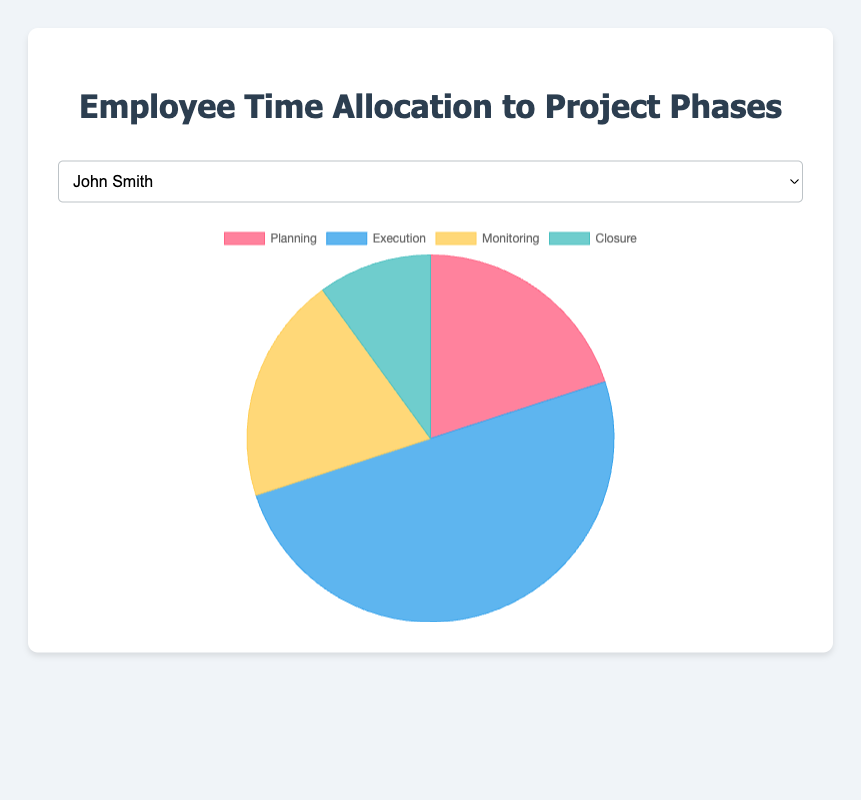What percentage of John's time is spent on Execution compared to Planning? Identify the 'Execution' time for John Smith, which is 50%. Identify the 'Planning' time, which is 20%. Compare these two values: 50% Execution is more than double the 20% Planning.
Answer: Execution is more than double Planning Which employee allocates the most time to Planning, and how much is it? Look at the Planning percentages for all employees and identify the maximum. Emily Davis spends 30% of her time on Planning, which is the highest among all employees.
Answer: Emily Davis, 30% For Lisa Johnson and Mark Brown, what is the combined percentage of time spent on Monitoring? Identify the Monitoring time for Lisa Johnson (20%) and Mark Brown (20%). The combined percentage is 20% + 20% = 40%.
Answer: 40% Who spends equal time on Monitoring and Closure? For each employee, compare the time spent on Monitoring and Closure. All employees (John, Lisa, Mark, Emily, Michael) spend 20% on Monitoring and 10% on Closure, which are not equal.
Answer: No one What is the average percentage of time spent on Execution across all employees? Sum the Execution percentages for all five employees: 50% + 45% + 55% + 40% + 52% = 242%. Divide by the number of employees (5). The average is 242%/5 = 48.4%.
Answer: 48.4% How much more time does Michael Wilson spend on Execution compared to Planning? Identify Michael Wilson's Execution time (52%) and Planning time (18%). Calculate the difference: 52% - 18% = 34%.
Answer: 34% Is there any employee whose time allocation for Execution and Monitoring combined equals or exceeds 70%? Add the Execution and Monitoring times for each employee. John Smith: 50% + 20% = 70%, Lisa Johnson: 45% + 20% = 65%, Mark Brown: 55% + 20% = 75%, Emily Davis: 40% + 20% = 60%, Michael Wilson: 52% + 20% = 72%. Both Mark Brown and Michael Wilson meet or exceed 70%.
Answer: Mark Brown and Michael Wilson Which employee has the smallest portion of their time spent in Closure? What is the percentage? All employees have the same percentage time allocated to Closure, which is 10%.
Answer: All employees, 10% Describe the visual difference in the chart between John Smith and Emily Davis in terms of Planning and Execution. In the pie chart, the section representing Planning for Emily Davis (30%) is significantly larger than for John Smith (20%). Conversely, the section for Execution in John Smith's chart (50%) is larger than in Emily Davis's chart (40%).
Answer: Emily has a larger Planning section and a smaller Execution section compared to John 